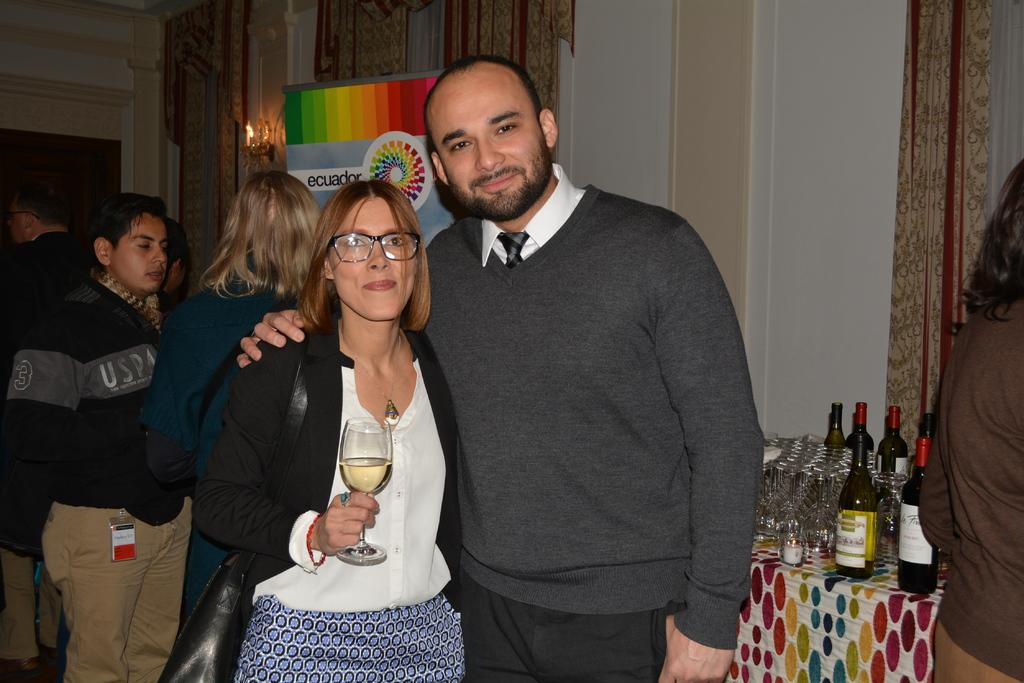How many people are present in the image? There are people in the image, but the exact number cannot be determined from the provided facts. What is the person holding in the image? The person is holding a glass with a drink. What can be seen on the table in the image? There are bottles and glasses on the table in the image. What can be seen in the background of the image? There are curtains, a wall, and a light in the background. What type of bell can be heard ringing in the image? There is no bell present or mentioned in the image, so it cannot be heard ringing. 